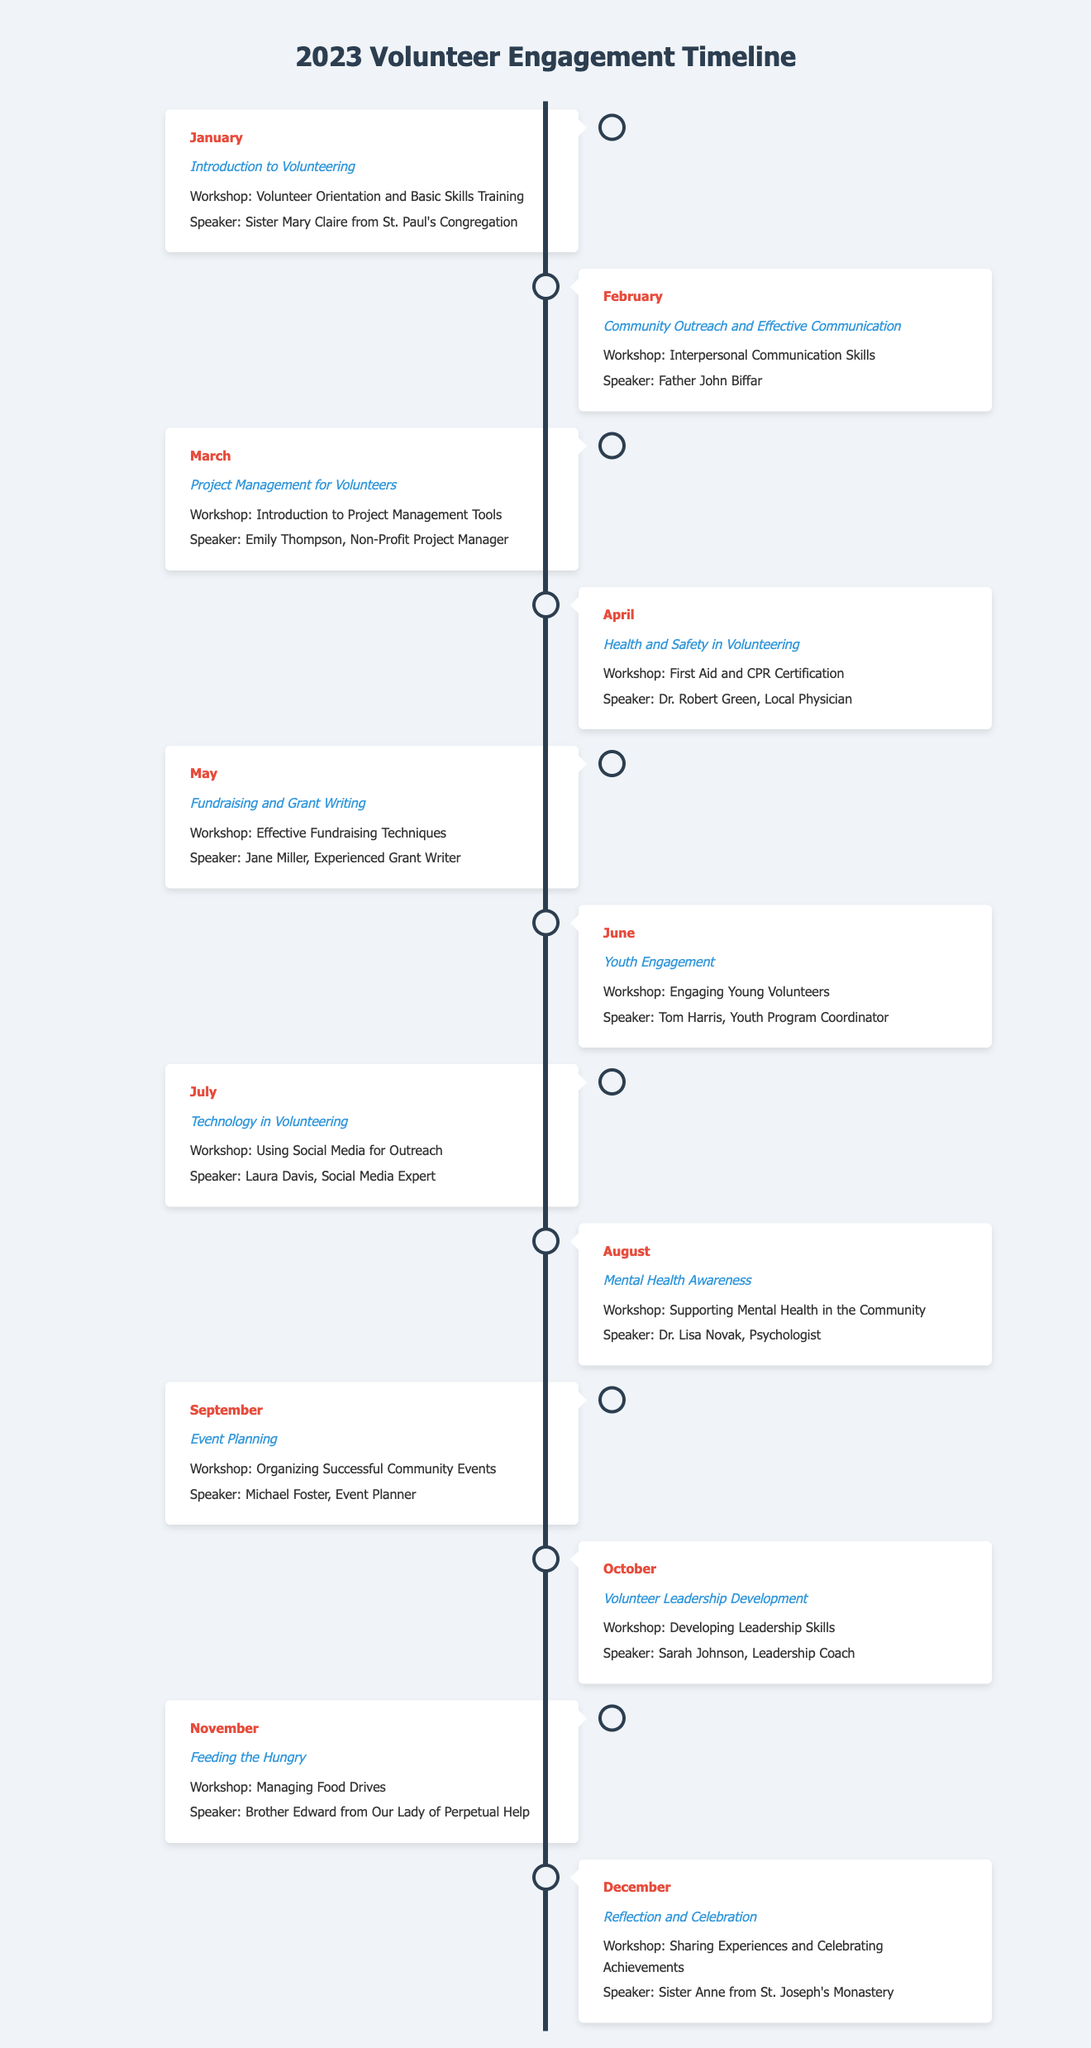What was the theme for January? The theme for January is mentioned alongside the month's activities and related workshops in the document.
Answer: Introduction to Volunteering Who was the speaker in May? The speaker for May is listed in the document under its respective month and content.
Answer: Jane Miller What workshop took place in April? This workshop is specified under April's content in the Timeline infographic.
Answer: First Aid and CPR Certification How many skill-building workshops were held in 2023? The document lists a workshop for each month, and there are twelve months in total.
Answer: 12 Which month featured a speaker from St. Joseph's Monastery? The specific month details the theme and speaker in the context of the activities for December.
Answer: December What is the theme for August? The theme is detailed for August, reflecting the focus of workshops for that month.
Answer: Mental Health Awareness Which month had a focus on Fundraising? The month is clearly indicated in the Timeline, detailing the workshop subject.
Answer: May Who led the workshop on Event Planning? The document provides information regarding the speaker alongside the respective month for this topic.
Answer: Michael Foster 